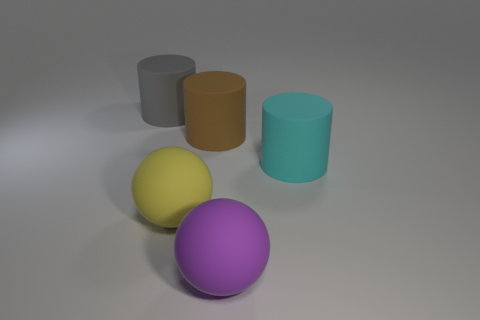Can you tell me what time of day it seems to be based on the lighting in the image? Based on the soft shadows and the neutral background, it suggests an indoor environment with artificial lighting rather than natural sunlight, making it challenging to determine the time of day from the image alone. 